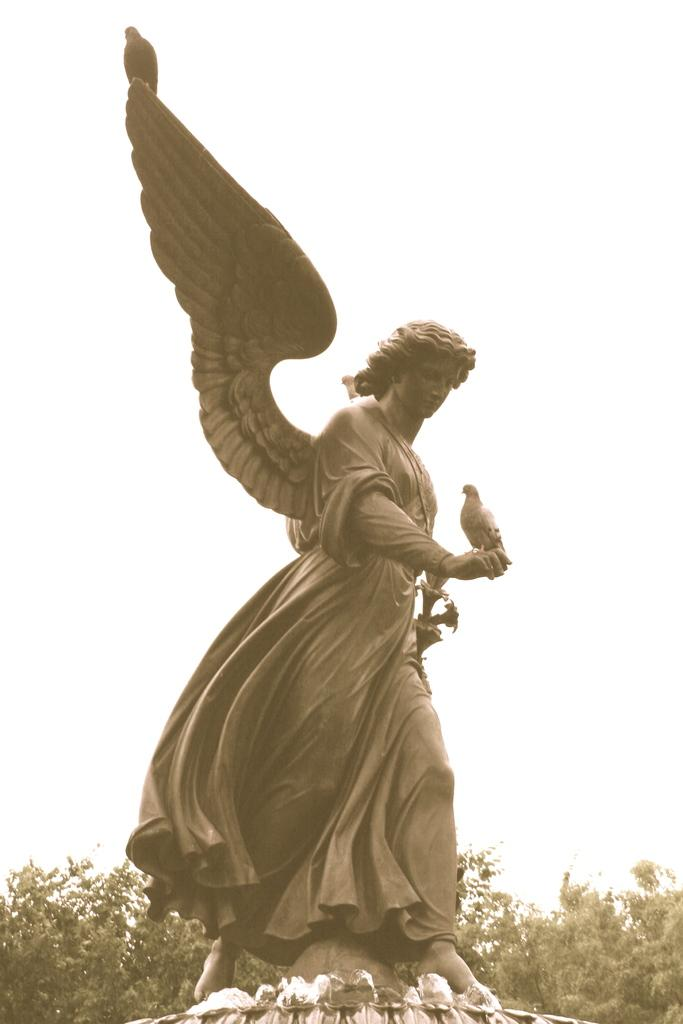What is the main subject of the image? There is a statue of a person with wings in the image. Are there any other elements on the statue? Yes, there is a bird on the statue. What can be seen in the background of the image? The sky is visible in the background of the image. What type of vegetation is present at the bottom of the image? Trees are present at the bottom of the image. What type of soup is being served in the image? There is no soup present in the image. Can you hear the song being played in the background of the image? There is no audio or music present in the image, so it is not possible to hear a song. 